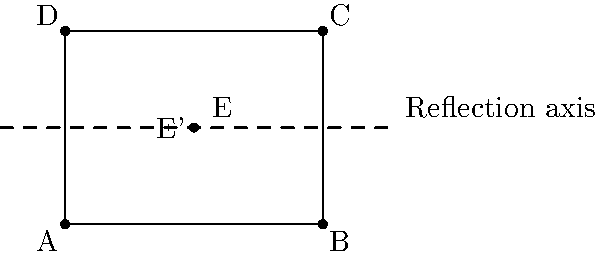In the exclusive mansion's landscape design shown above, point E represents a unique water feature. If the entire design is to be reflected across the dashed line to create perfect symmetry, what are the coordinates of the reflected point E'? To find the coordinates of the reflected point E', we need to follow these steps:

1. Identify the original coordinates of point E: $(2, 1.5)$

2. Determine the equation of the reflection axis (dashed line):
   The line passes through points $(-1, 1.5)$ and $(5, 1.5)$, so its equation is $y = 1.5$

3. Use the reflection formula for a point across a horizontal line:
   If a point $(x, y)$ is reflected across the line $y = k$, its image is $(x, 2k - y)$

4. Apply the formula to point E$(2, 1.5)$:
   $x' = x = 2$
   $y' = 2k - y = 2(1.5) - 1.5 = 1.5$

5. Therefore, the coordinates of E' are $(2, 1.5)$

We can observe that point E is actually on the reflection axis, so its reflection E' coincides with itself.
Answer: $(2, 1.5)$ 